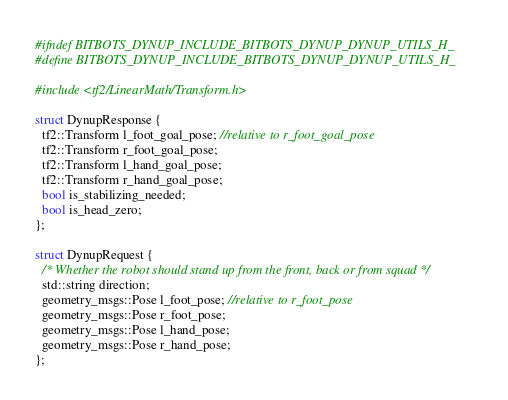<code> <loc_0><loc_0><loc_500><loc_500><_C_>#ifndef BITBOTS_DYNUP_INCLUDE_BITBOTS_DYNUP_DYNUP_UTILS_H_
#define BITBOTS_DYNUP_INCLUDE_BITBOTS_DYNUP_DYNUP_UTILS_H_

#include <tf2/LinearMath/Transform.h>

struct DynupResponse {
  tf2::Transform l_foot_goal_pose; //relative to r_foot_goal_pose
  tf2::Transform r_foot_goal_pose;
  tf2::Transform l_hand_goal_pose;
  tf2::Transform r_hand_goal_pose;
  bool is_stabilizing_needed;
  bool is_head_zero;
};

struct DynupRequest {
  /* Whether the robot should stand up from the front, back or from squad */
  std::string direction;
  geometry_msgs::Pose l_foot_pose; //relative to r_foot_pose
  geometry_msgs::Pose r_foot_pose;
  geometry_msgs::Pose l_hand_pose;
  geometry_msgs::Pose r_hand_pose;
};
</code> 